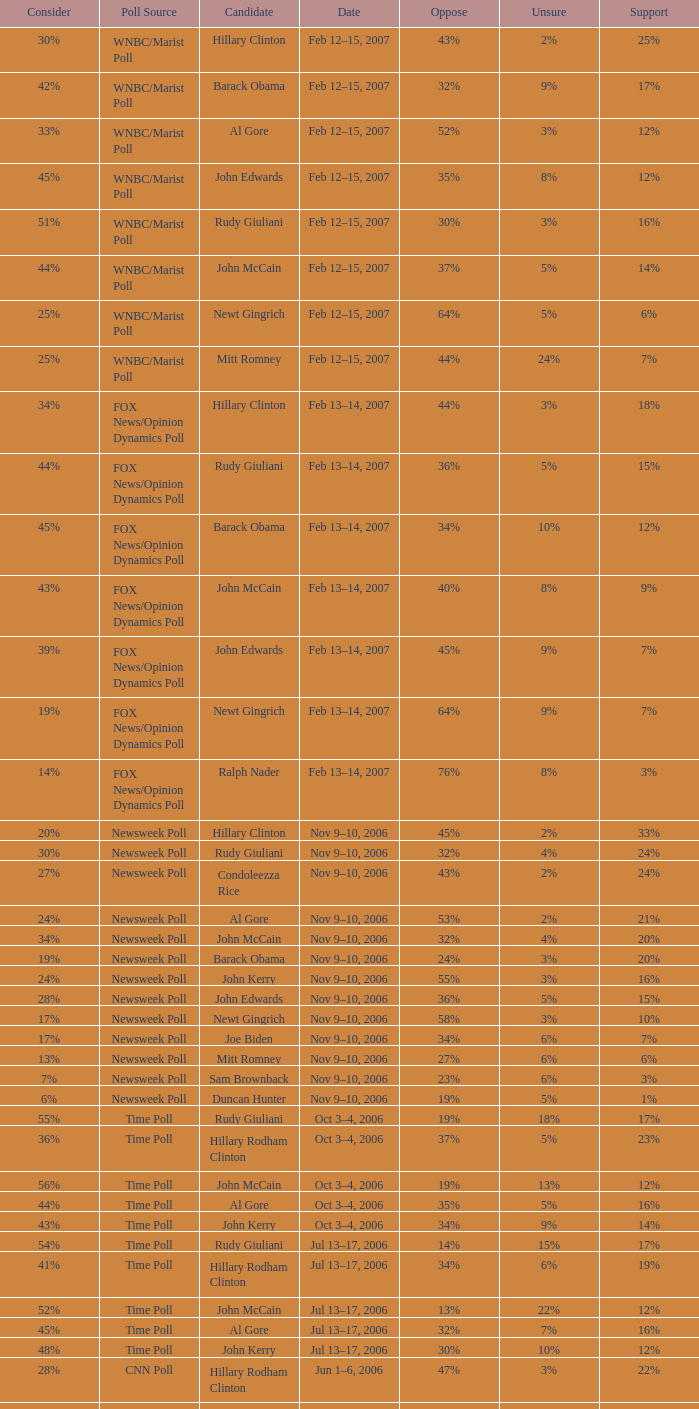What percentage of people said they would consider Rudy Giuliani as a candidate according to the Newsweek poll that showed 32% opposed him? 30%. 